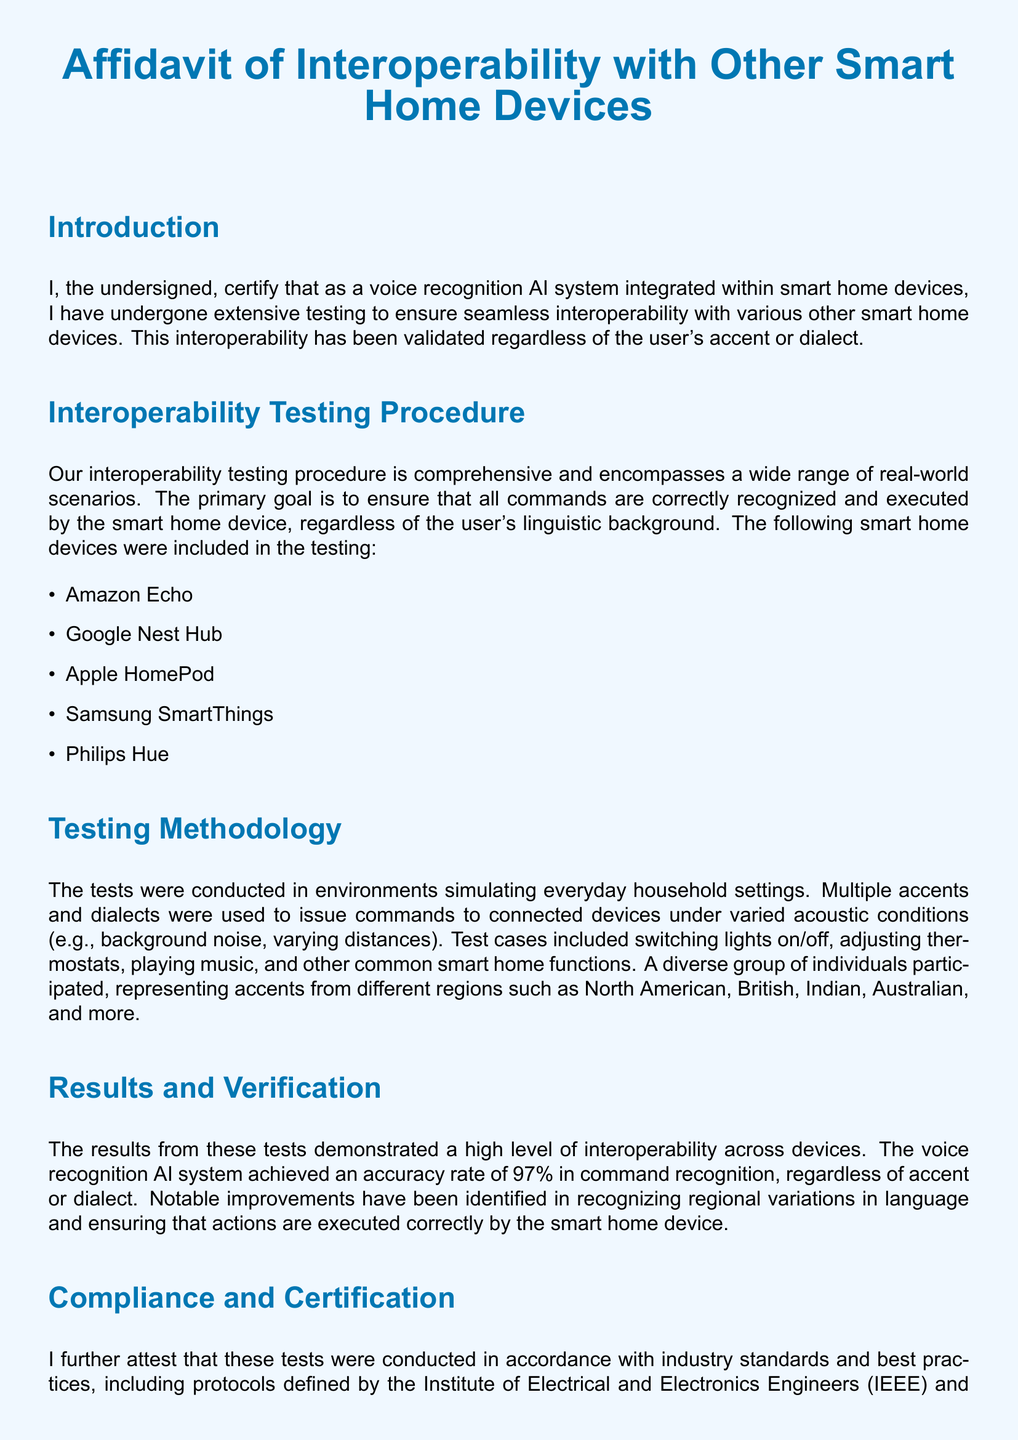What is the title of the document? The title is given at the top of the document as the main heading.
Answer: Affidavit of Interoperability with Other Smart Home Devices What is the accuracy rate achieved by the voice recognition AI system? The accuracy rate is specified in the results section of the document.
Answer: 97% Which organization conducted third-party validation? The document lists specific companies that confirmed the reliability of the results.
Answer: Intertek and TÜV Rheinland What types of smart home devices were included in the testing? The document enumerates specific smart home devices within the testing procedure.
Answer: Amazon Echo, Google Nest Hub, Apple HomePod, Samsung SmartThings, Philips Hue What linguistic backgrounds were represented in the testing procedure? The document describes the diverse group of individuals who participated in the tests.
Answer: North American, British, Indian, Australian, and more What is the primary goal of the interoperability testing? The document states the main goal of the tests in the introduction.
Answer: Ensure that all commands are correctly recognized and executed What protocols were followed during the testing? The document refers to standards adhered to during the testing process.
Answer: Institute of Electrical and Electronics Engineers (IEEE) and International Organization for Standardization (ISO) Who is the authorized signatory of the document? The document includes a signature section indicating the signatory title.
Answer: Voice Recognition AI System for Smart Home Devices 